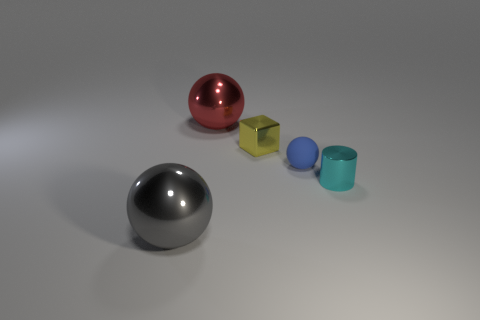Is there any other thing that has the same material as the small ball?
Ensure brevity in your answer.  No. Is the number of large shiny objects right of the large gray object greater than the number of blue rubber cylinders?
Offer a very short reply. Yes. What number of objects are metal things to the left of the tiny yellow cube or small shiny objects right of the small rubber ball?
Ensure brevity in your answer.  3. The yellow thing that is made of the same material as the cyan thing is what size?
Your response must be concise. Small. Do the large thing that is behind the big gray shiny thing and the big gray thing have the same shape?
Offer a terse response. Yes. What number of brown things are either matte spheres or small objects?
Your answer should be very brief. 0. How many other objects are the same shape as the red shiny object?
Give a very brief answer. 2. What is the shape of the object that is in front of the metal cube and left of the cube?
Ensure brevity in your answer.  Sphere. Are there any things on the right side of the tiny cyan metallic cylinder?
Provide a succinct answer. No. The blue thing that is the same shape as the big red object is what size?
Give a very brief answer. Small. 